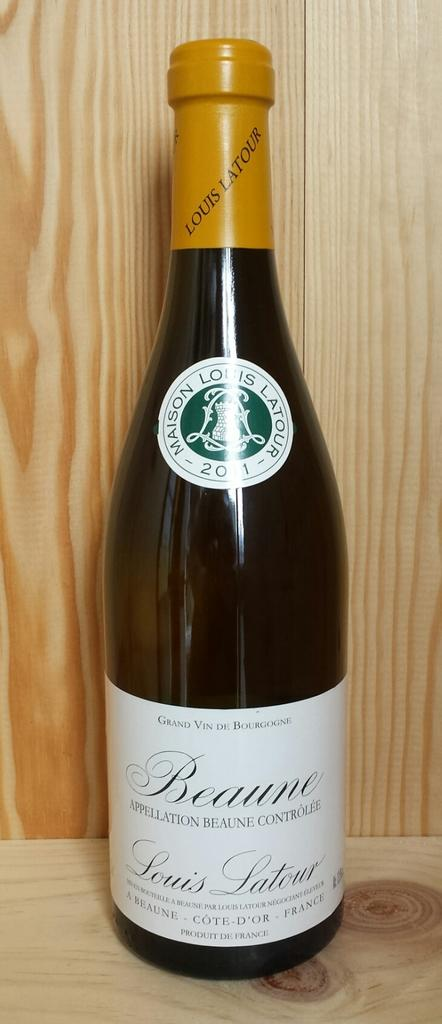<image>
Write a terse but informative summary of the picture. A bottle of Beaune French wine is prominently displayed. 